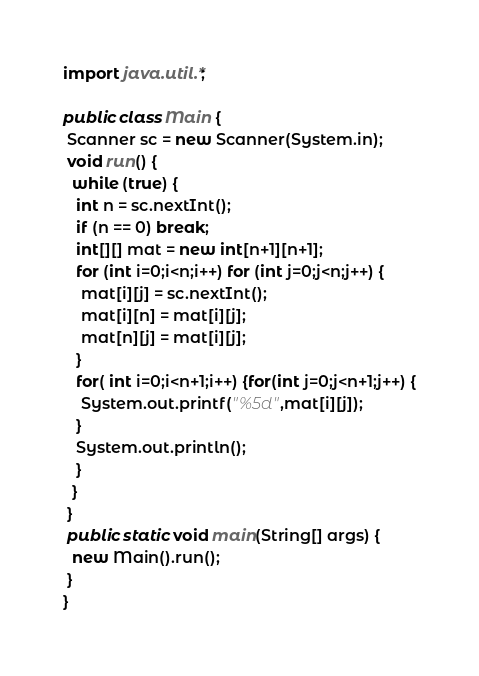<code> <loc_0><loc_0><loc_500><loc_500><_Java_>import java.util.*;

public class Main {
 Scanner sc = new Scanner(System.in);
 void run() {
  while (true) {
   int n = sc.nextInt();
   if (n == 0) break;
   int[][] mat = new int[n+1][n+1];
   for (int i=0;i<n;i++) for (int j=0;j<n;j++) {
    mat[i][j] = sc.nextInt();
    mat[i][n] = mat[i][j];
    mat[n][j] = mat[i][j];
   }
   for( int i=0;i<n+1;i++) {for(int j=0;j<n+1;j++) {
    System.out.printf("%5d",mat[i][j]);
   }
   System.out.println();
   }
  }
 }
 public static void main(String[] args) {
  new Main().run();
 }
}</code> 